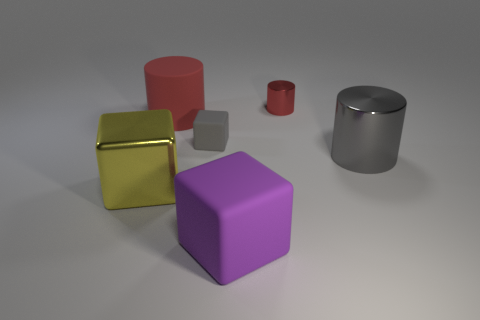Subtract all matte cylinders. How many cylinders are left? 2 Subtract all purple spheres. How many red cylinders are left? 2 Add 3 big metallic cylinders. How many objects exist? 9 Subtract all cyan cylinders. Subtract all brown blocks. How many cylinders are left? 3 Subtract all large spheres. Subtract all rubber things. How many objects are left? 3 Add 1 tiny metallic objects. How many tiny metallic objects are left? 2 Add 5 red cylinders. How many red cylinders exist? 7 Subtract 0 yellow spheres. How many objects are left? 6 